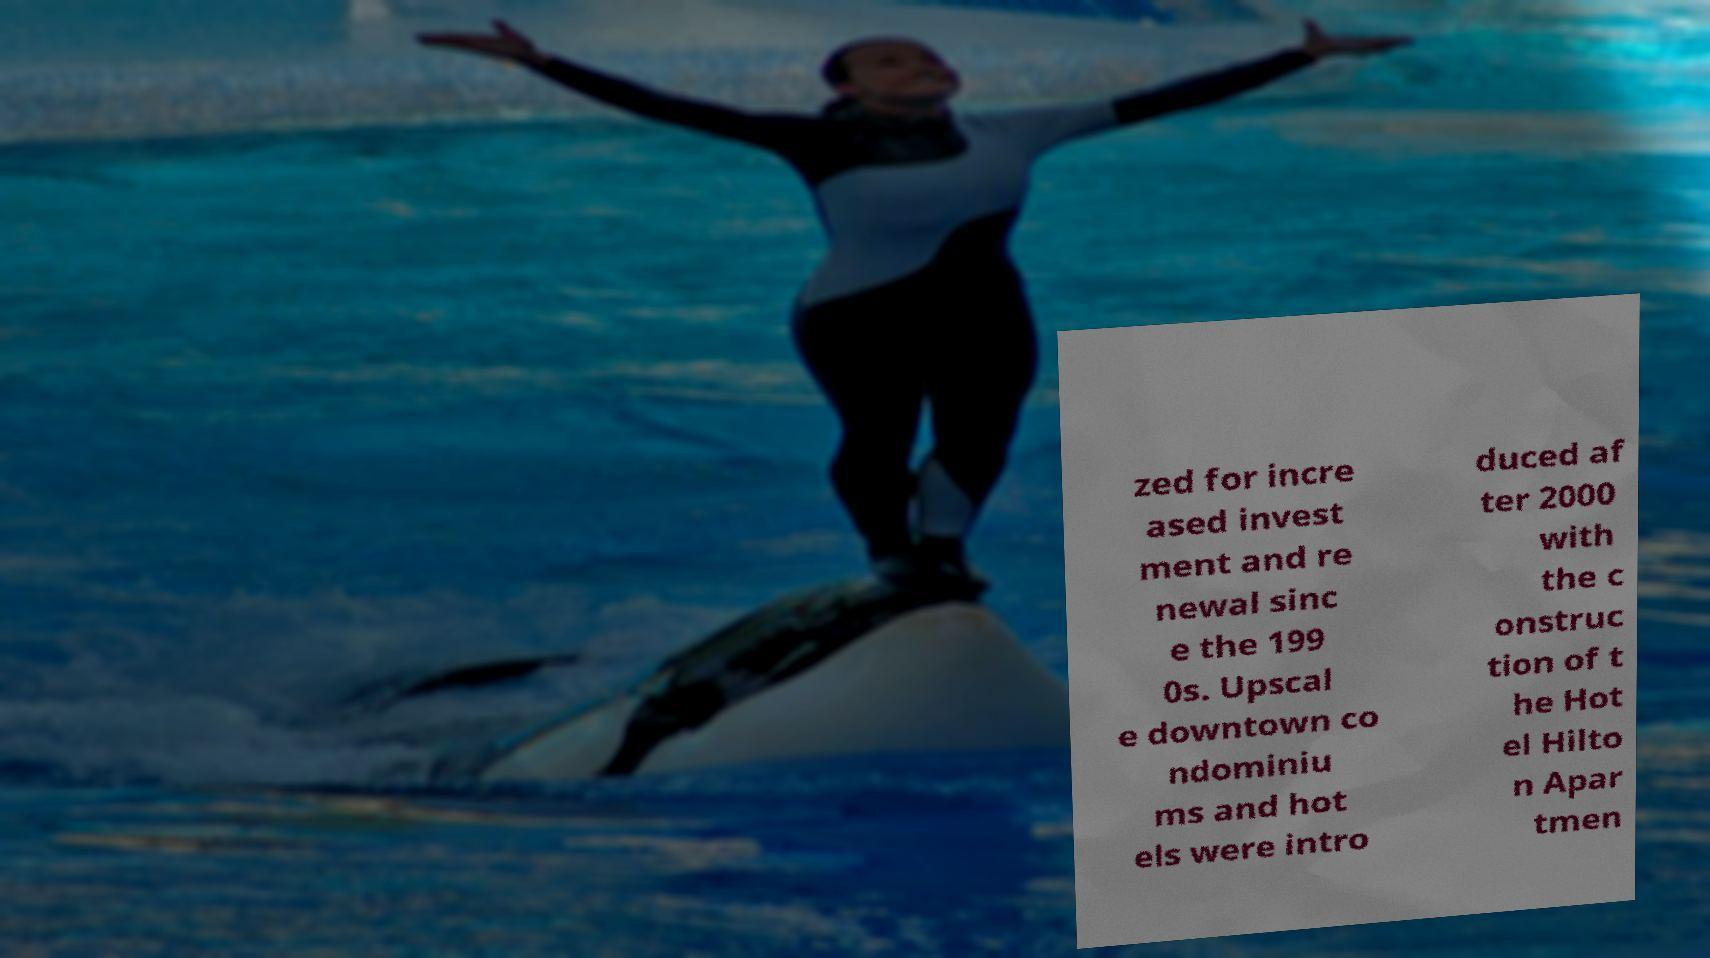Can you accurately transcribe the text from the provided image for me? zed for incre ased invest ment and re newal sinc e the 199 0s. Upscal e downtown co ndominiu ms and hot els were intro duced af ter 2000 with the c onstruc tion of t he Hot el Hilto n Apar tmen 